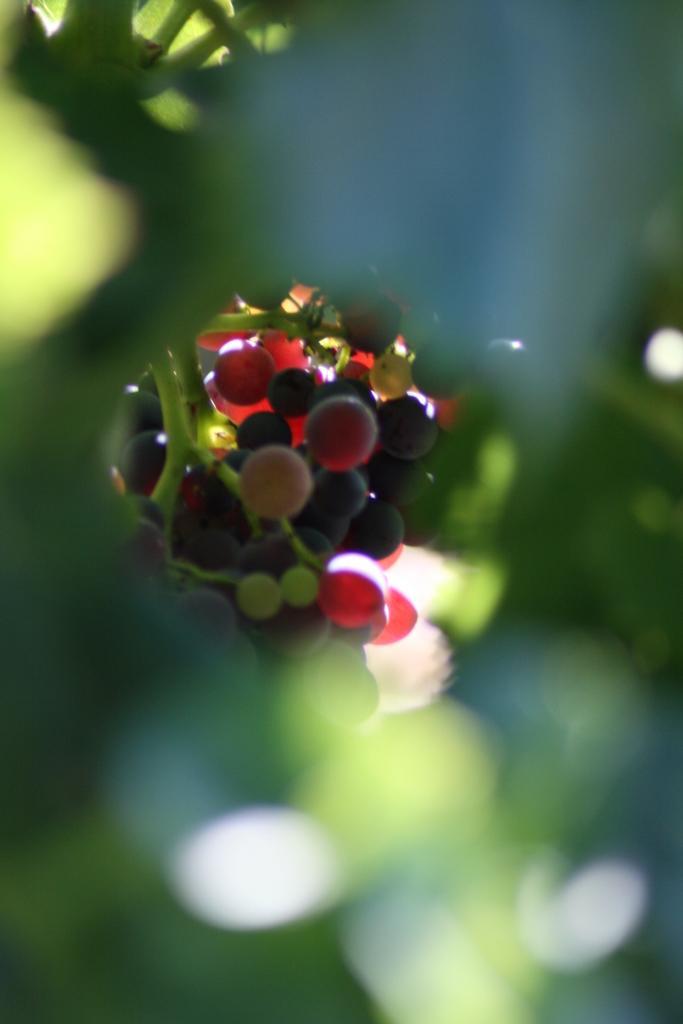Can you describe this image briefly? In this picture I can see the green color things in front and I see that it is blurred. In the background I can see the berries which are of red and black color. 